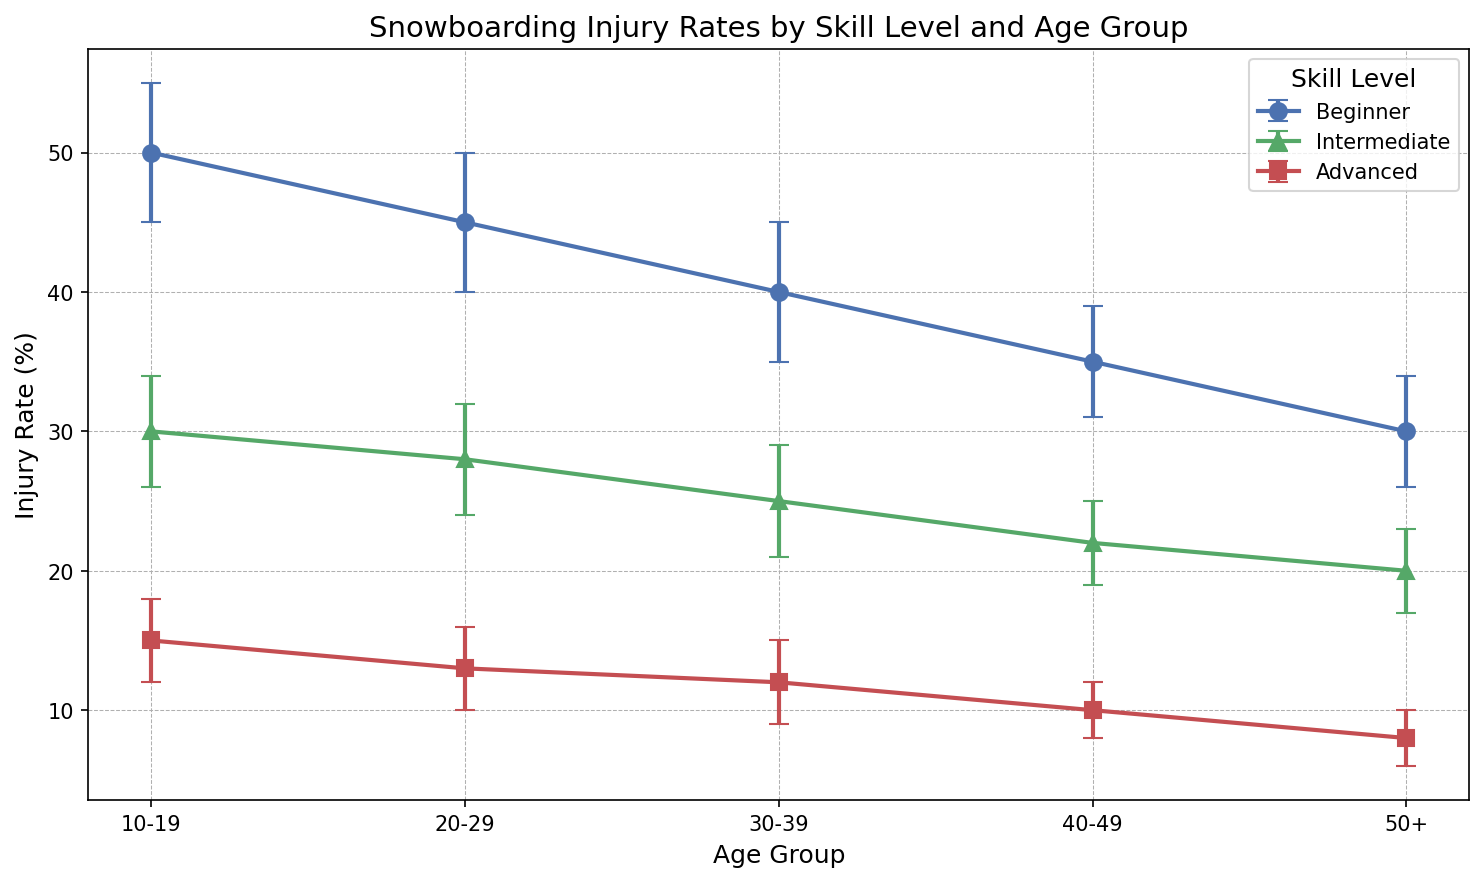How many more beginner injuries are there in the 10-19 age group compared to the 50+ age group? In the 10-19 age group, the injury rate for beginners is 50%. In the 50+ age group, the injury rate for beginners is 30%. The difference is 50 - 30 = 20.
Answer: 20 Which skill level has the lowest injury rate in the 20-29 age group? In the 20-29 age group, the injury rates for beginner, intermediate, and advanced skill levels are 45%, 28%, and 13%, respectively. The advanced skill level has the lowest injury rate of 13%.
Answer: Advanced What is the average injury rate for intermediate skill level across all age groups? The injury rates for intermediate skill level in the age groups are 30%, 28%, 25%, 22%, and 20%. The average injury rate is (30 + 28 + 25 + 22 + 20) / 5 = 25%.
Answer: 25 By how much does the injury rate for beginners decrease from the 10-19 age group to the 30-39 age group? The injury rate for beginners in the 10-19 age group is 50%, and in the 30-39 age group, it is 40%. The decrease is 50 - 40 = 10%.
Answer: 10 What is the total injury rate for advanced skill level across all age groups? The injury rates for advanced skill level in the age groups are 15%, 13%, 12%, 10%, and 8%. The total injury rate is 15 + 13 + 12 + 10 + 8 = 58%.
Answer: 58 Which age group shows the largest error margin for intermediate skill level? The error margins for intermediate skill level in each age group are 4%, 4%, 4%, 3%, and 3%. The 10-19 and 20-29 age groups have the largest error margin at 4%.
Answer: 10-19, 20-29 Between which two consecutive age groups does the injury rate for advanced skill level decrease the most? The decrease in injury rate for advanced skill level from 10-19 to 20-29 is 15 - 13 = 2%, from 20-29 to 30-39 is 13 - 12 = 1%, from 30-39 to 40-49 is 12 - 10 = 2%, and from 40-49 to 50+ is 10 - 8 = 2%. The decrease is the same (2%) between 10-19 to 20-29, 30-39 to 40-49, and 40-49 to 50+.
Answer: 10-19 to 20-29, 30-39 to 40-49, 40-49 to 50+ How does the injury rate for beginners change visually in the plot across age groups? The injury rate for beginners is represented by blue circles. It starts high at 50% in the 10-19 age group, then gradually decreases through the age groups, ending at 30% in the 50+ age group.
Answer: Decreases Which skill level has green markers on the plot and what does it signify with respect to the injury rates? Intermediate skill level is represented by green markers. It signifies that the injury rates for intermediate skill levels are consistently between the rates for beginner and advanced skill levels across all age groups.
Answer: Intermediate skill level 